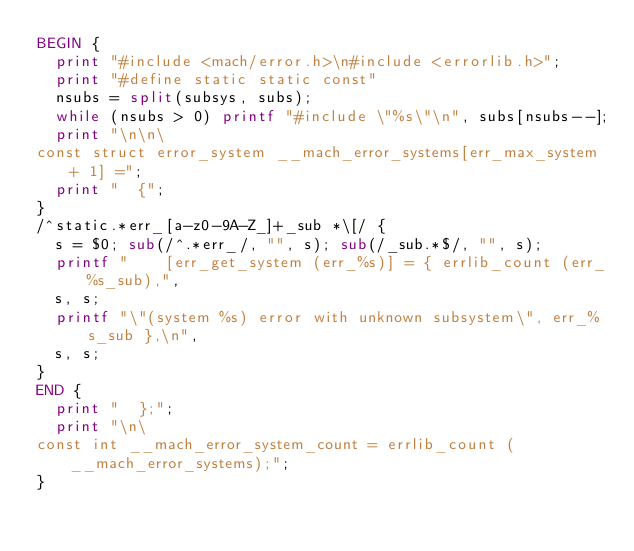Convert code to text. <code><loc_0><loc_0><loc_500><loc_500><_Awk_>BEGIN {
  print "#include <mach/error.h>\n#include <errorlib.h>";
  print "#define static static const"
  nsubs = split(subsys, subs);
  while (nsubs > 0) printf "#include \"%s\"\n", subs[nsubs--];
  print "\n\n\
const struct error_system __mach_error_systems[err_max_system + 1] =";
  print "  {";
}
/^static.*err_[a-z0-9A-Z_]+_sub *\[/ {
  s = $0; sub(/^.*err_/, "", s); sub(/_sub.*$/, "", s);
  printf "    [err_get_system (err_%s)] = { errlib_count (err_%s_sub),",
	s, s;
  printf "\"(system %s) error with unknown subsystem\", err_%s_sub },\n",
	s, s;
}
END {
  print "  };";
  print "\n\
const int __mach_error_system_count = errlib_count (__mach_error_systems);";
}
</code> 